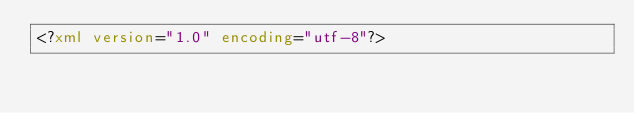Convert code to text. <code><loc_0><loc_0><loc_500><loc_500><_XML_><?xml version="1.0" encoding="utf-8"?></code> 